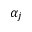<formula> <loc_0><loc_0><loc_500><loc_500>\alpha _ { j }</formula> 